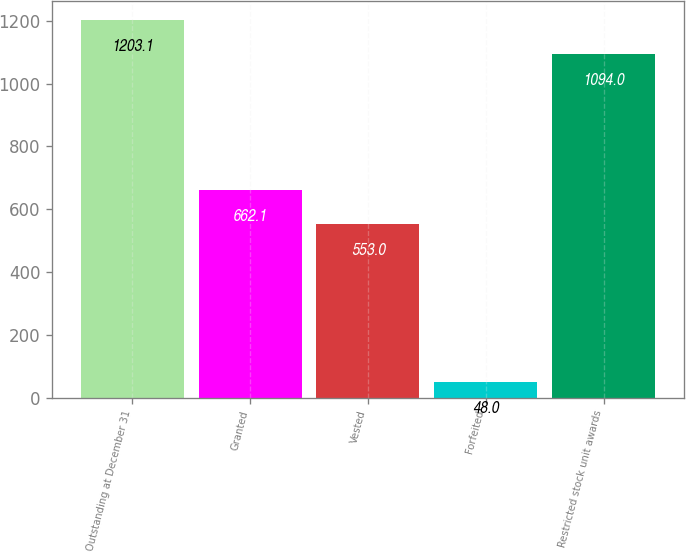Convert chart. <chart><loc_0><loc_0><loc_500><loc_500><bar_chart><fcel>Outstanding at December 31<fcel>Granted<fcel>Vested<fcel>Forfeited<fcel>Restricted stock unit awards<nl><fcel>1203.1<fcel>662.1<fcel>553<fcel>48<fcel>1094<nl></chart> 